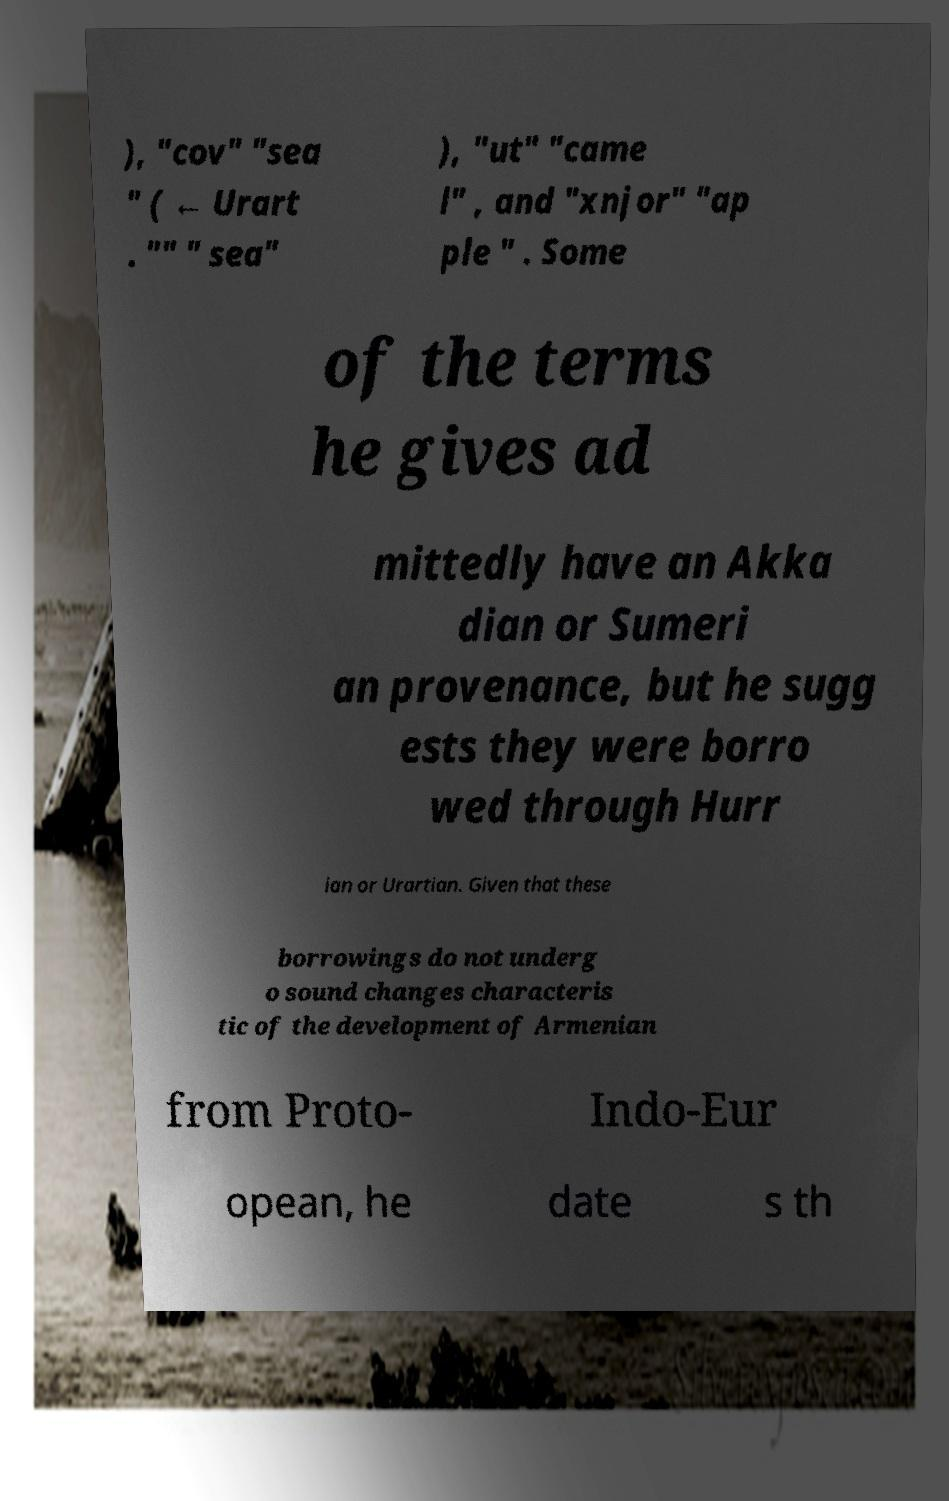Could you extract and type out the text from this image? ), "cov" "sea " ( ← Urart . "" " sea" ), "ut" "came l" , and "xnjor" "ap ple " . Some of the terms he gives ad mittedly have an Akka dian or Sumeri an provenance, but he sugg ests they were borro wed through Hurr ian or Urartian. Given that these borrowings do not underg o sound changes characteris tic of the development of Armenian from Proto- Indo-Eur opean, he date s th 